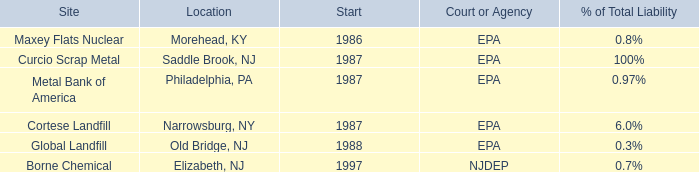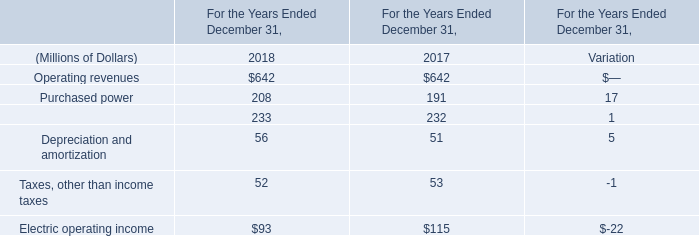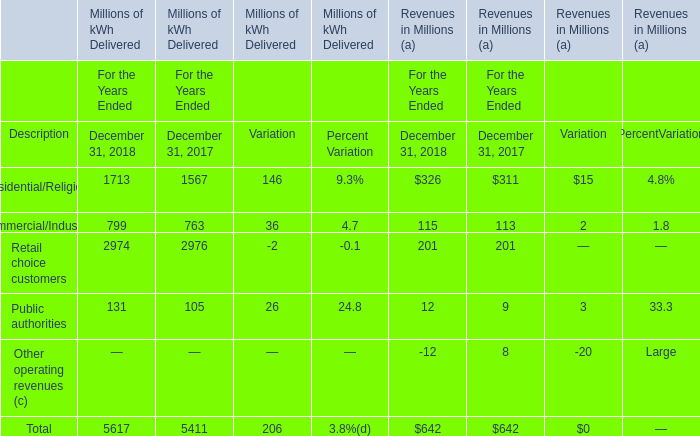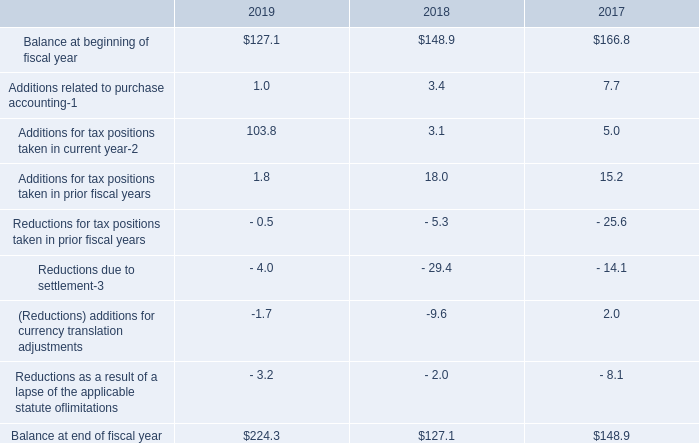What's the total value of all elements that are in the range of 200 and 700 in 2018? (in Million) 
Computations: ((642 + 208) + 233)
Answer: 1083.0. 